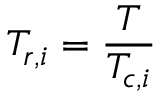Convert formula to latex. <formula><loc_0><loc_0><loc_500><loc_500>T _ { r , i } = \frac { T } { T _ { c , i } }</formula> 